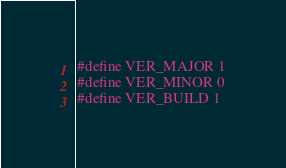Convert code to text. <code><loc_0><loc_0><loc_500><loc_500><_C_>#define VER_MAJOR 1
#define VER_MINOR 0
#define VER_BUILD 1

</code> 